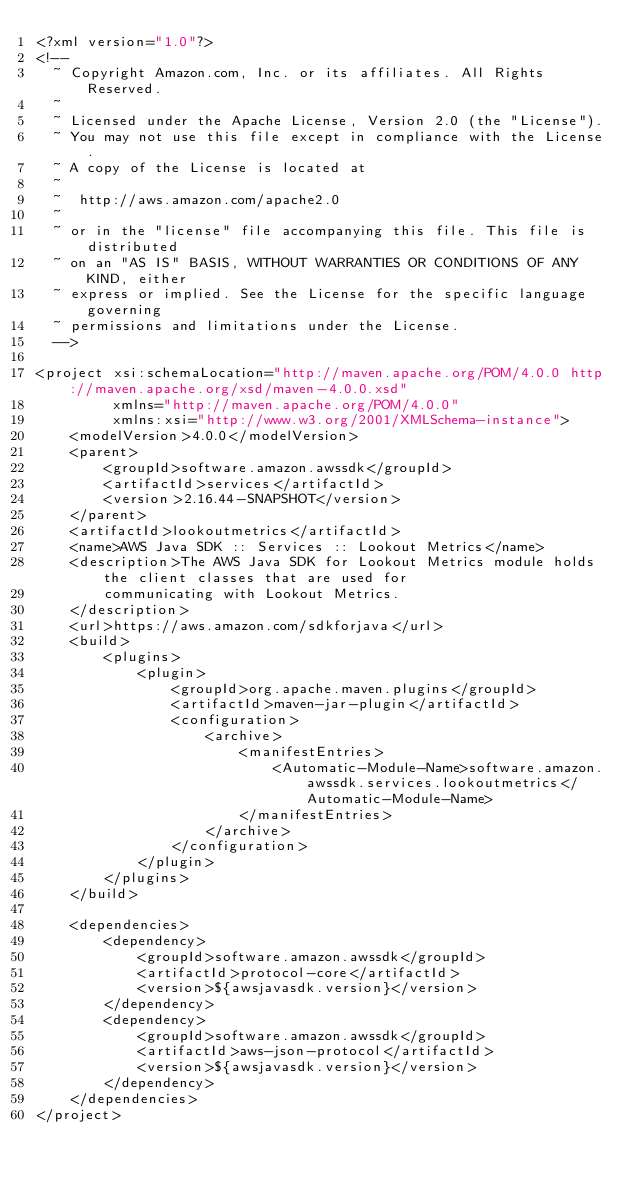Convert code to text. <code><loc_0><loc_0><loc_500><loc_500><_XML_><?xml version="1.0"?>
<!--
  ~ Copyright Amazon.com, Inc. or its affiliates. All Rights Reserved.
  ~
  ~ Licensed under the Apache License, Version 2.0 (the "License").
  ~ You may not use this file except in compliance with the License.
  ~ A copy of the License is located at
  ~
  ~  http://aws.amazon.com/apache2.0
  ~
  ~ or in the "license" file accompanying this file. This file is distributed
  ~ on an "AS IS" BASIS, WITHOUT WARRANTIES OR CONDITIONS OF ANY KIND, either
  ~ express or implied. See the License for the specific language governing
  ~ permissions and limitations under the License.
  -->

<project xsi:schemaLocation="http://maven.apache.org/POM/4.0.0 http://maven.apache.org/xsd/maven-4.0.0.xsd"
         xmlns="http://maven.apache.org/POM/4.0.0"
         xmlns:xsi="http://www.w3.org/2001/XMLSchema-instance">
    <modelVersion>4.0.0</modelVersion>
    <parent>
        <groupId>software.amazon.awssdk</groupId>
        <artifactId>services</artifactId>
        <version>2.16.44-SNAPSHOT</version>
    </parent>
    <artifactId>lookoutmetrics</artifactId>
    <name>AWS Java SDK :: Services :: Lookout Metrics</name>
    <description>The AWS Java SDK for Lookout Metrics module holds the client classes that are used for
        communicating with Lookout Metrics.
    </description>
    <url>https://aws.amazon.com/sdkforjava</url>
    <build>
        <plugins>
            <plugin>
                <groupId>org.apache.maven.plugins</groupId>
                <artifactId>maven-jar-plugin</artifactId>
                <configuration>
                    <archive>
                        <manifestEntries>
                            <Automatic-Module-Name>software.amazon.awssdk.services.lookoutmetrics</Automatic-Module-Name>
                        </manifestEntries>
                    </archive>
                </configuration>
            </plugin>
        </plugins>
    </build>

    <dependencies>
        <dependency>
            <groupId>software.amazon.awssdk</groupId>
            <artifactId>protocol-core</artifactId>
            <version>${awsjavasdk.version}</version>
        </dependency>
        <dependency>
            <groupId>software.amazon.awssdk</groupId>
            <artifactId>aws-json-protocol</artifactId>
            <version>${awsjavasdk.version}</version>
        </dependency>
    </dependencies>
</project>
</code> 